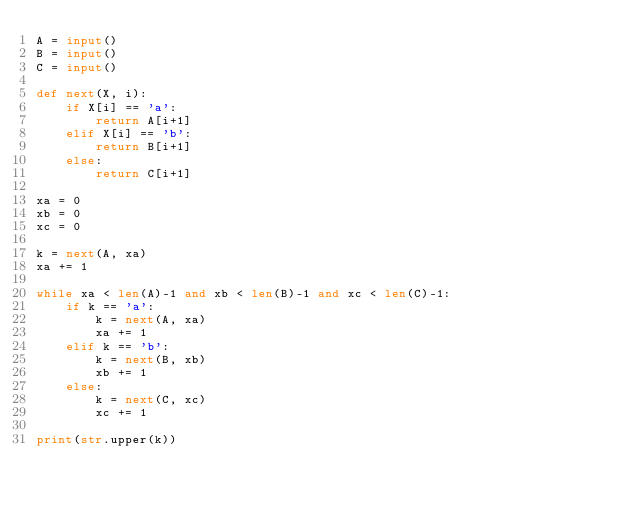Convert code to text. <code><loc_0><loc_0><loc_500><loc_500><_Python_>A = input()
B = input()
C = input()

def next(X, i):
    if X[i] == 'a':
        return A[i+1]
    elif X[i] == 'b':
        return B[i+1]
    else:
        return C[i+1]

xa = 0
xb = 0
xc = 0

k = next(A, xa)
xa += 1

while xa < len(A)-1 and xb < len(B)-1 and xc < len(C)-1:
    if k == 'a':
        k = next(A, xa)
        xa += 1
    elif k == 'b':
        k = next(B, xb)
        xb += 1
    else:
        k = next(C, xc)
        xc += 1

print(str.upper(k))
</code> 